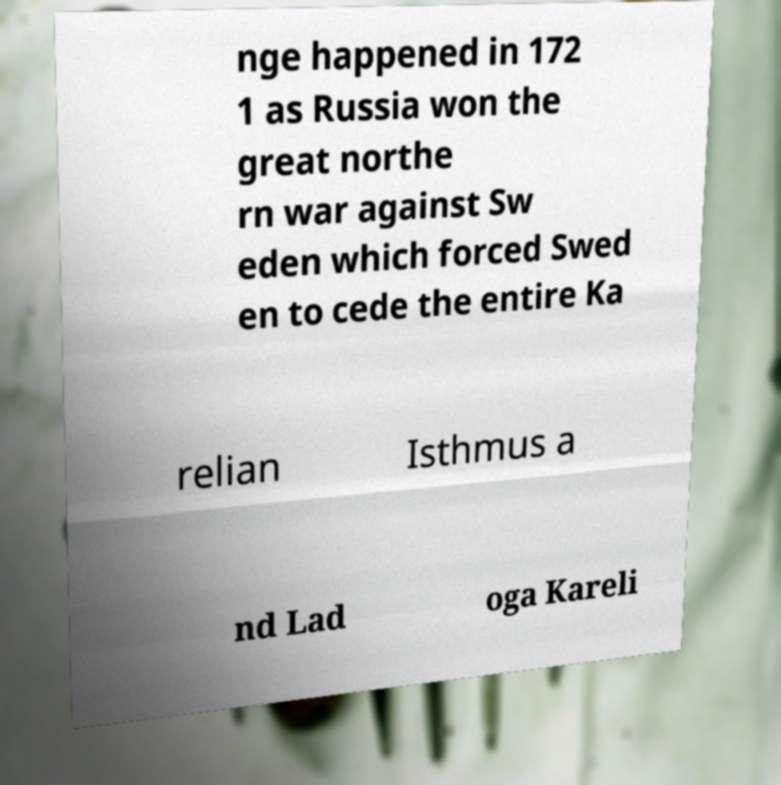Please read and relay the text visible in this image. What does it say? nge happened in 172 1 as Russia won the great northe rn war against Sw eden which forced Swed en to cede the entire Ka relian Isthmus a nd Lad oga Kareli 